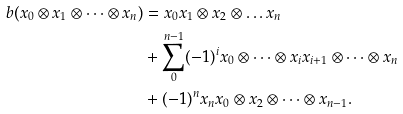<formula> <loc_0><loc_0><loc_500><loc_500>b ( x _ { 0 } \otimes x _ { 1 } \otimes \dots \otimes x _ { n } ) & = x _ { 0 } x _ { 1 } \otimes x _ { 2 } \otimes \dots x _ { n } \\ & + \sum _ { 0 } ^ { n - 1 } ( - 1 ) ^ { i } x _ { 0 } \otimes \dots \otimes x _ { i } x _ { i + 1 } \otimes \dots \otimes x _ { n } \\ & + ( - 1 ) ^ { n } x _ { n } x _ { 0 } \otimes x _ { 2 } \otimes \dots \otimes x _ { n - 1 } .</formula> 